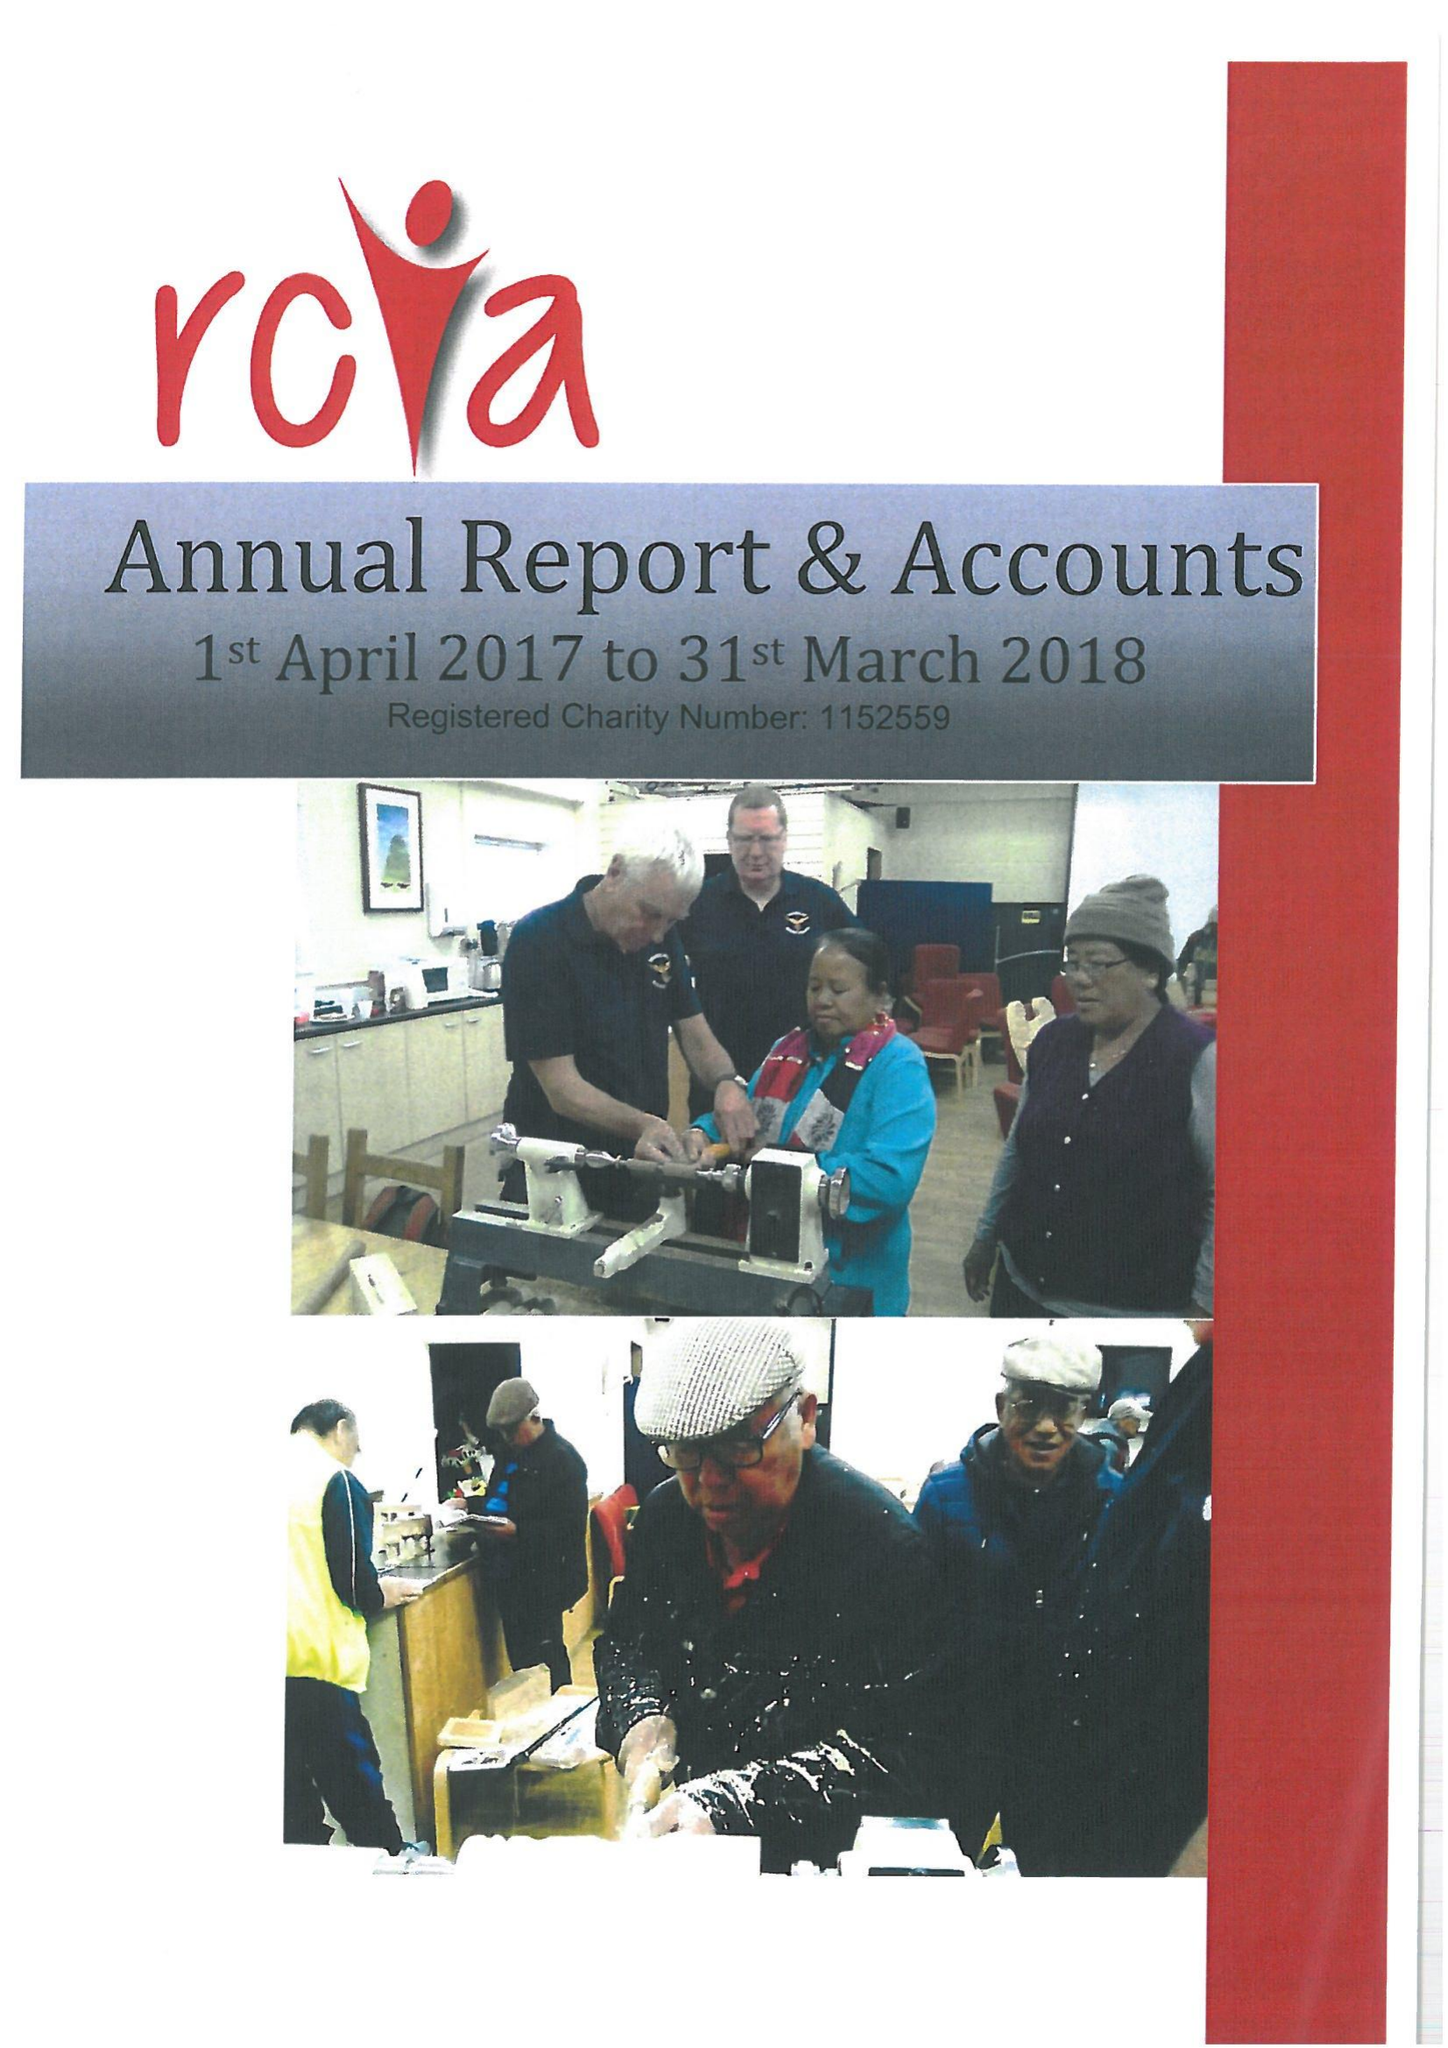What is the value for the charity_number?
Answer the question using a single word or phrase. 1152559 